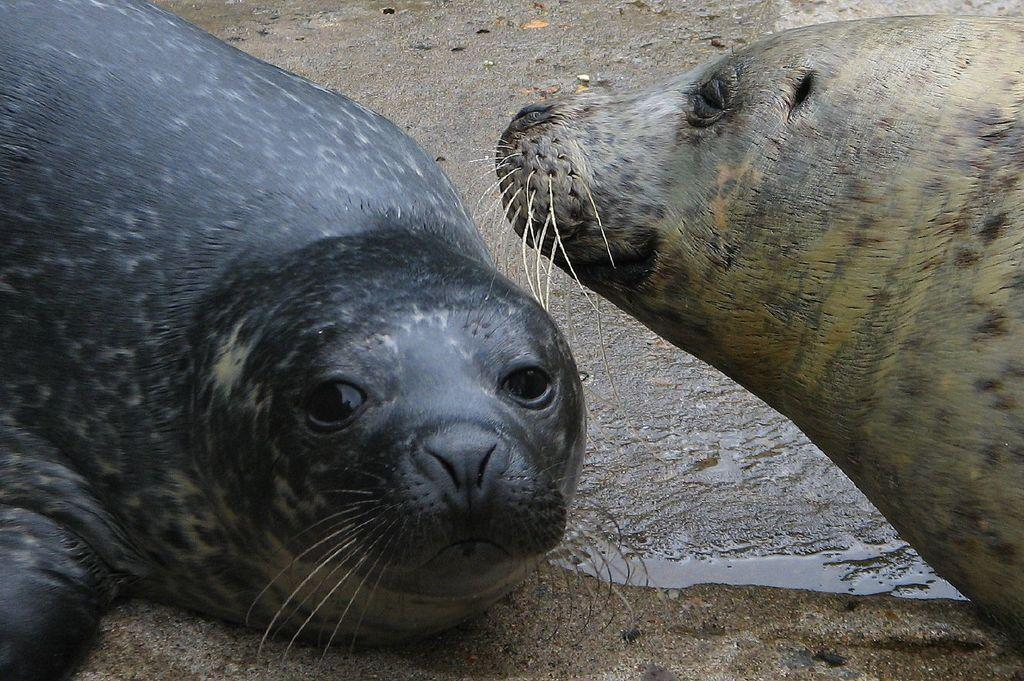What animals are present in the image? There are two sea lions in the image. What is the surface on which the sea lions are standing? The sea lions are on the wet ground. What type of guide is assisting the yak in the image? There is no guide or yak present in the image; it features two sea lions on the wet ground. 